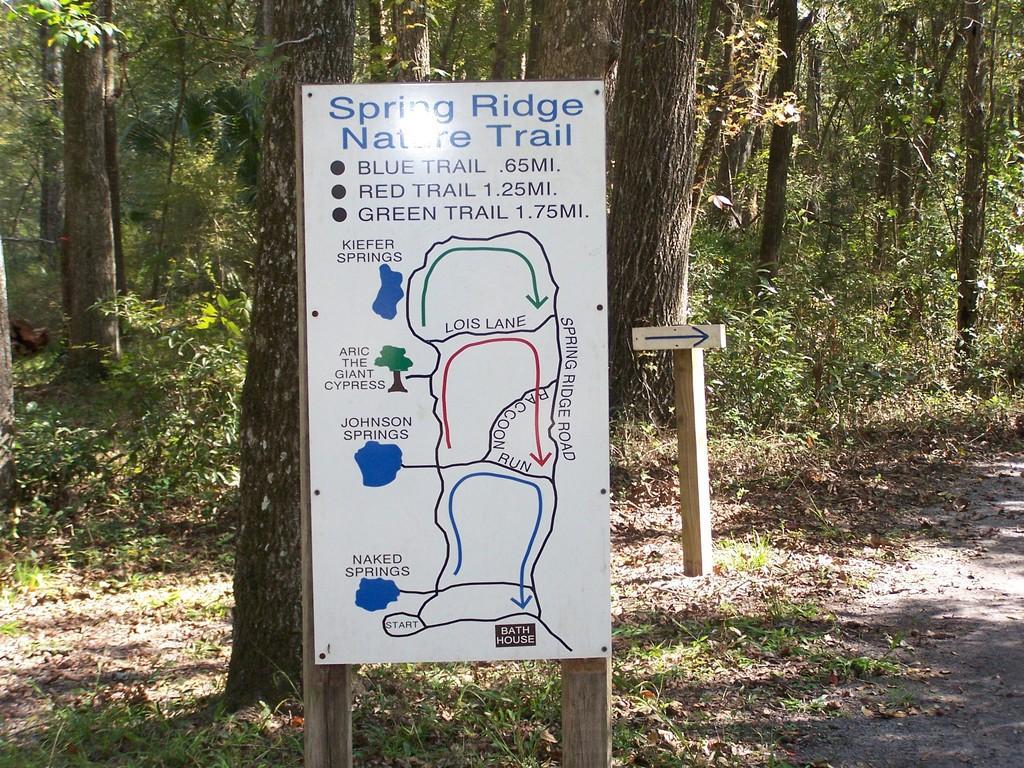Can you describe this image briefly? In this picture we can see boards on wooden poles, leaves and grass. In the background of the image we can see trees. 